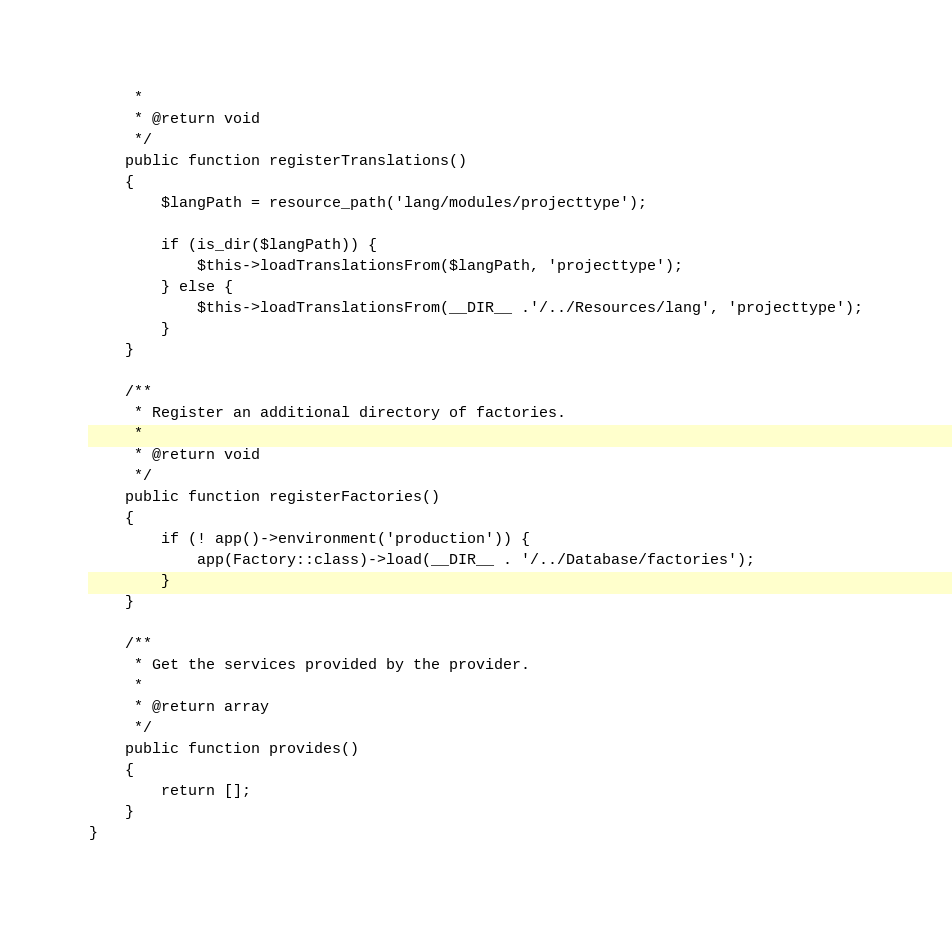Convert code to text. <code><loc_0><loc_0><loc_500><loc_500><_PHP_>     *
     * @return void
     */
    public function registerTranslations()
    {
        $langPath = resource_path('lang/modules/projecttype');

        if (is_dir($langPath)) {
            $this->loadTranslationsFrom($langPath, 'projecttype');
        } else {
            $this->loadTranslationsFrom(__DIR__ .'/../Resources/lang', 'projecttype');
        }
    }

    /**
     * Register an additional directory of factories.
     *
     * @return void
     */
    public function registerFactories()
    {
        if (! app()->environment('production')) {
            app(Factory::class)->load(__DIR__ . '/../Database/factories');
        }
    }

    /**
     * Get the services provided by the provider.
     *
     * @return array
     */
    public function provides()
    {
        return [];
    }
}
</code> 